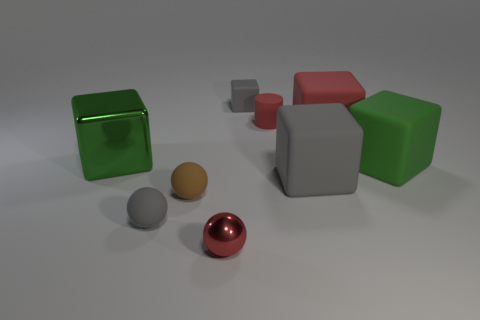Are there more green blocks to the right of the large gray matte thing than big metallic things to the right of the small matte block?
Keep it short and to the point. Yes. What number of other things are the same color as the rubber cylinder?
Keep it short and to the point. 2. There is a tiny shiny sphere; does it have the same color as the big block that is behind the big metal cube?
Your answer should be compact. Yes. How many red things are on the right side of the gray object that is behind the red matte cube?
Your answer should be compact. 2. There is a tiny gray thing that is right of the small gray rubber thing that is to the left of the tiny gray matte object that is right of the red shiny thing; what is it made of?
Your answer should be very brief. Rubber. What is the object that is both to the right of the brown sphere and left of the tiny cube made of?
Your answer should be very brief. Metal. How many large green rubber things are the same shape as the brown matte thing?
Give a very brief answer. 0. What is the size of the shiny object that is behind the red sphere in front of the green matte block?
Make the answer very short. Large. Does the metallic object that is right of the large metal object have the same color as the big matte block that is behind the big green matte block?
Ensure brevity in your answer.  Yes. There is a gray matte block that is to the right of the gray rubber object behind the large red object; what number of metal blocks are right of it?
Your answer should be compact. 0. 